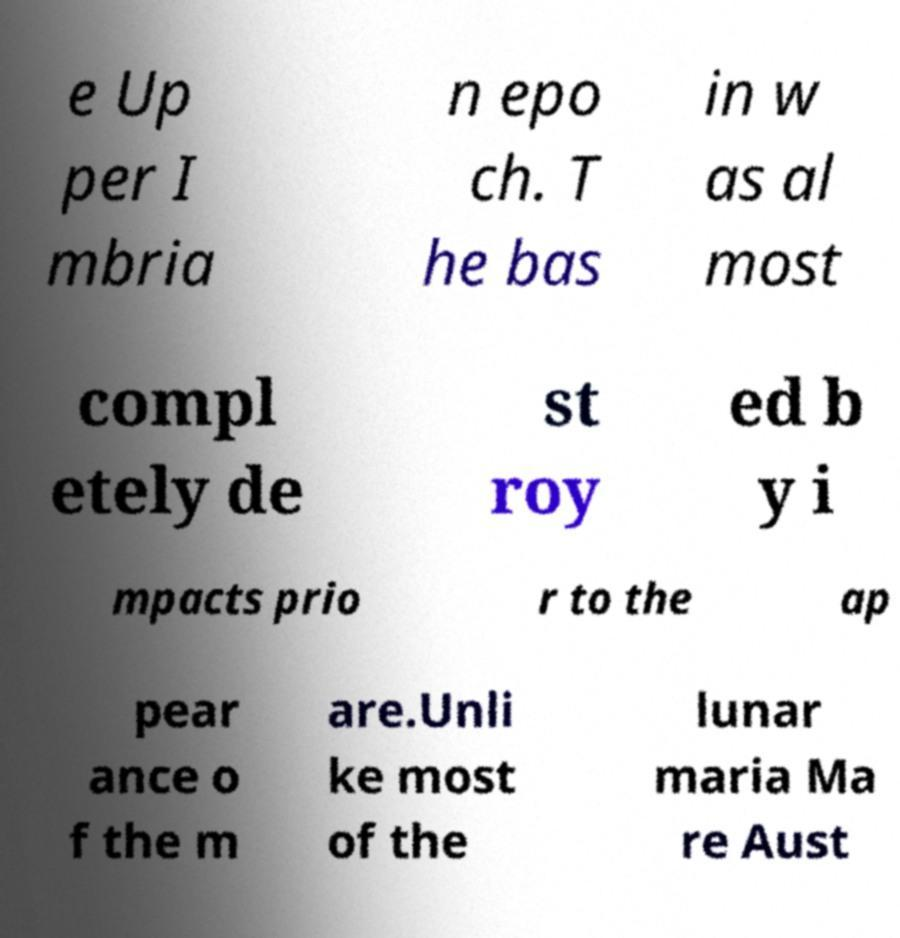I need the written content from this picture converted into text. Can you do that? e Up per I mbria n epo ch. T he bas in w as al most compl etely de st roy ed b y i mpacts prio r to the ap pear ance o f the m are.Unli ke most of the lunar maria Ma re Aust 